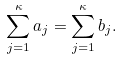Convert formula to latex. <formula><loc_0><loc_0><loc_500><loc_500>\sum _ { j = 1 } ^ { \kappa } a _ { j } = \sum _ { j = 1 } ^ { \kappa } b _ { j } .</formula> 